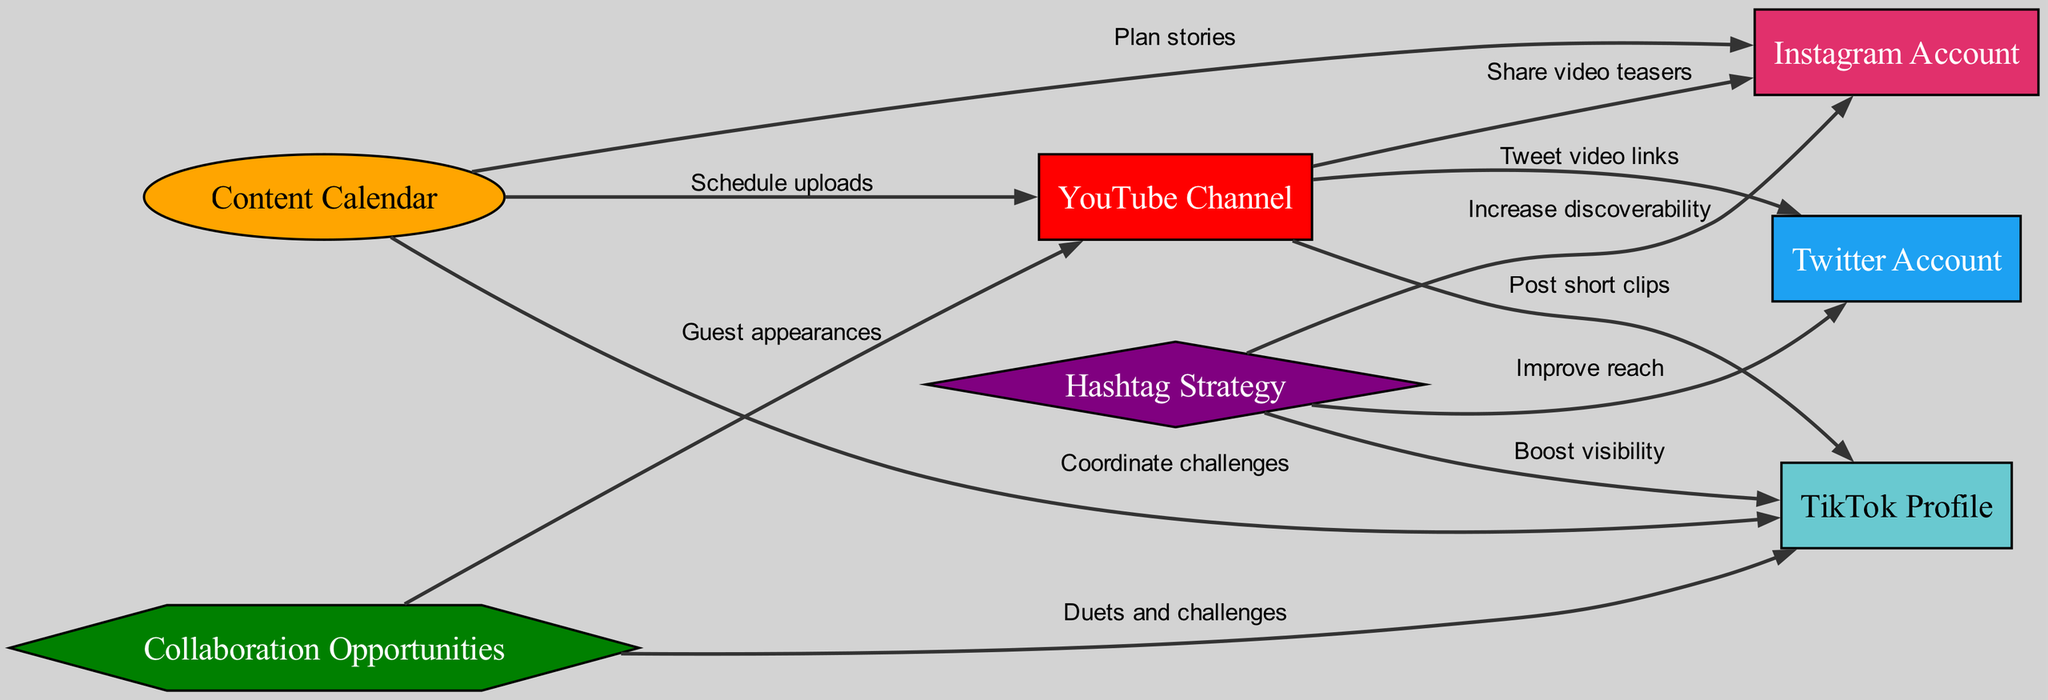What is the main platform for video content in this strategy? The node labeled "YouTube Channel" is prominently featured as the central hub of the strategy, indicating it is the primary platform for video content.
Answer: YouTube Channel How many social media accounts are included in the diagram? Counting the nodes representing social media accounts, there are four: Instagram Account, TikTok Profile, and Twitter Account.
Answer: 4 Which node focuses on scheduling activities? The "Content Calendar" node is labeled and positioned to indicate its role in managing and scheduling uploads across platforms.
Answer: Content Calendar What type of task is linked to the Instagram Account from the YouTube Channel? The edge labeled "Share video teasers" indicates that the task involved is to promote video content on Instagram.
Answer: Share video teasers What type of strategy is represented by the node with a diamond shape? The node labeled "Hashtag Strategy" is designed in a diamond shape, distinguishing it as a unique strategy for improving discoverability on social media.
Answer: Hashtag Strategy Which two platforms include the label "Boost visibility"? The nodes connected by the label "Boost visibility" are TikTok Profile and the Hashtag Strategy, indicating their relationship in increasing the profile's visibility.
Answer: TikTok Profile and Hashtag Strategy How many edges connect the YouTube Channel to other nodes? There are three edges connecting the YouTube Channel to other nodes: to Instagram Account, TikTok Profile, and Twitter Account.
Answer: 3 What is the purpose of the "Collaboration Opportunities" node in relation to the YouTube Channel? "Collaboration Opportunities" is connected to the YouTube Channel, indicating its role in fostering guest appearances, thus enhancing content diversity and reach.
Answer: Guest appearances What is the relationship between the Content Calendar and the TikTok Profile? The "Coordinate challenges" edge indicates that the Content Calendar helps plan and manage challenges that can be posted on the TikTok Profile.
Answer: Coordinate challenges 